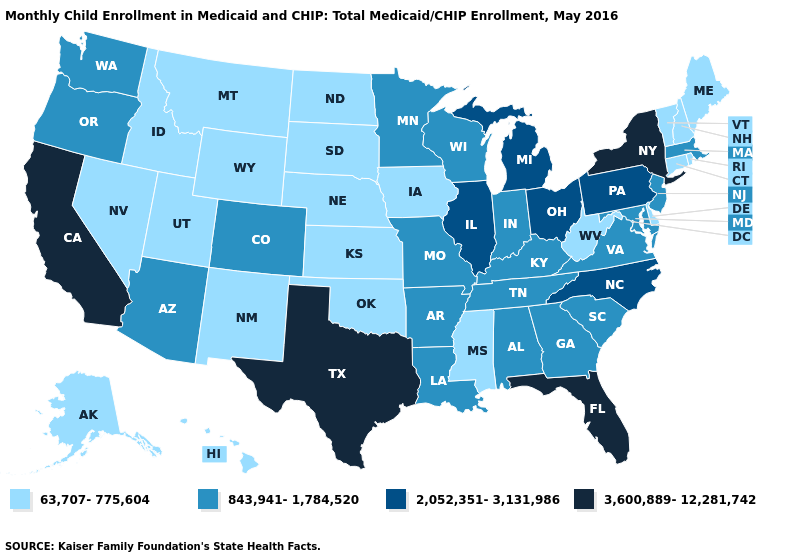Which states have the lowest value in the South?
Be succinct. Delaware, Mississippi, Oklahoma, West Virginia. Among the states that border Minnesota , which have the lowest value?
Give a very brief answer. Iowa, North Dakota, South Dakota. Among the states that border Arizona , does New Mexico have the lowest value?
Give a very brief answer. Yes. Among the states that border South Dakota , does North Dakota have the lowest value?
Answer briefly. Yes. Name the states that have a value in the range 843,941-1,784,520?
Give a very brief answer. Alabama, Arizona, Arkansas, Colorado, Georgia, Indiana, Kentucky, Louisiana, Maryland, Massachusetts, Minnesota, Missouri, New Jersey, Oregon, South Carolina, Tennessee, Virginia, Washington, Wisconsin. What is the value of Florida?
Keep it brief. 3,600,889-12,281,742. What is the lowest value in the MidWest?
Concise answer only. 63,707-775,604. What is the highest value in the Northeast ?
Short answer required. 3,600,889-12,281,742. Name the states that have a value in the range 3,600,889-12,281,742?
Short answer required. California, Florida, New York, Texas. Name the states that have a value in the range 2,052,351-3,131,986?
Write a very short answer. Illinois, Michigan, North Carolina, Ohio, Pennsylvania. What is the value of North Dakota?
Answer briefly. 63,707-775,604. Does Alaska have the same value as Kansas?
Concise answer only. Yes. What is the value of Illinois?
Give a very brief answer. 2,052,351-3,131,986. Among the states that border Delaware , does Pennsylvania have the highest value?
Short answer required. Yes. What is the value of Georgia?
Concise answer only. 843,941-1,784,520. 